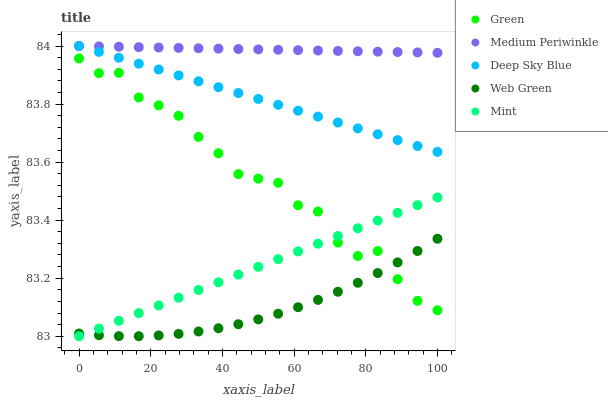Does Web Green have the minimum area under the curve?
Answer yes or no. Yes. Does Medium Periwinkle have the maximum area under the curve?
Answer yes or no. Yes. Does Mint have the minimum area under the curve?
Answer yes or no. No. Does Mint have the maximum area under the curve?
Answer yes or no. No. Is Mint the smoothest?
Answer yes or no. Yes. Is Green the roughest?
Answer yes or no. Yes. Is Green the smoothest?
Answer yes or no. No. Is Mint the roughest?
Answer yes or no. No. Does Mint have the lowest value?
Answer yes or no. Yes. Does Green have the lowest value?
Answer yes or no. No. Does Deep Sky Blue have the highest value?
Answer yes or no. Yes. Does Mint have the highest value?
Answer yes or no. No. Is Mint less than Deep Sky Blue?
Answer yes or no. Yes. Is Deep Sky Blue greater than Web Green?
Answer yes or no. Yes. Does Medium Periwinkle intersect Deep Sky Blue?
Answer yes or no. Yes. Is Medium Periwinkle less than Deep Sky Blue?
Answer yes or no. No. Is Medium Periwinkle greater than Deep Sky Blue?
Answer yes or no. No. Does Mint intersect Deep Sky Blue?
Answer yes or no. No. 